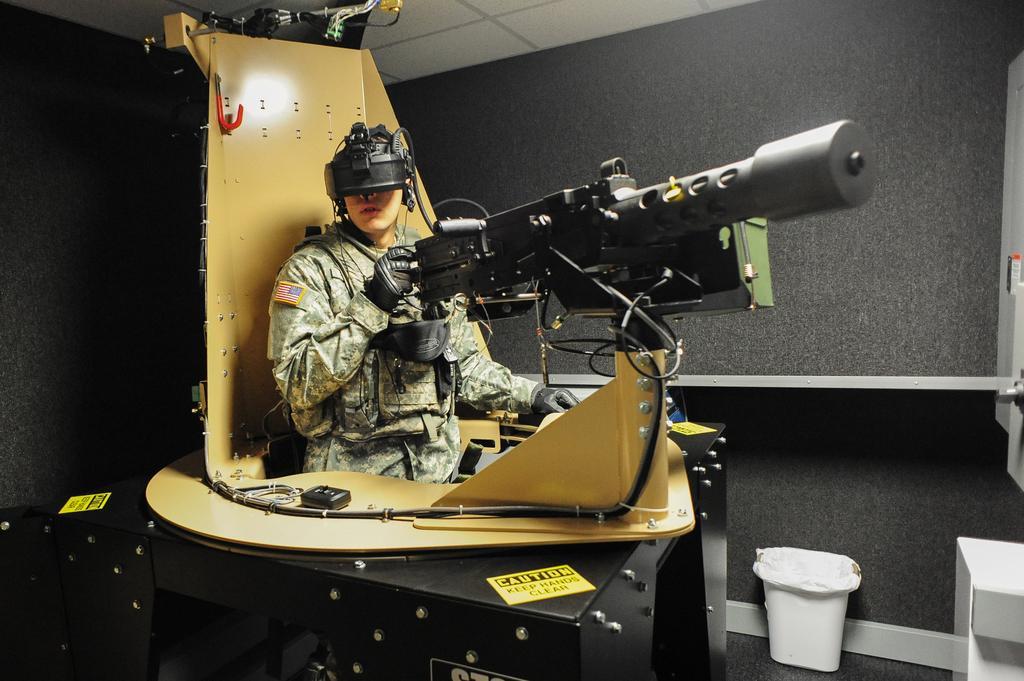Please provide a concise description of this image. In this picture we can see a person is holding an object and in front of the person there are cables. On the right side of the person there is a dustbin on the path. Behind the person there is a wall and an object. 